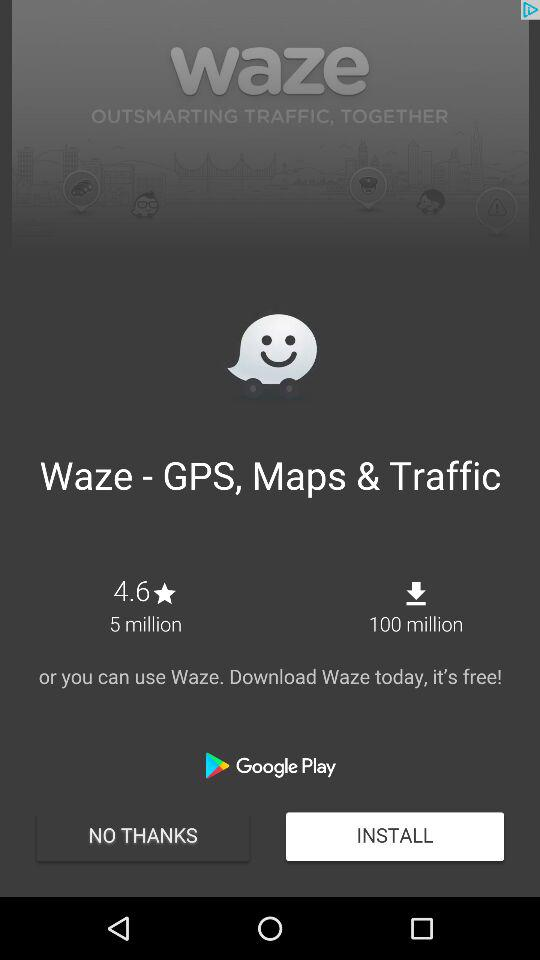How many more downloads does Waze have than reviews?
Answer the question using a single word or phrase. 95 million 